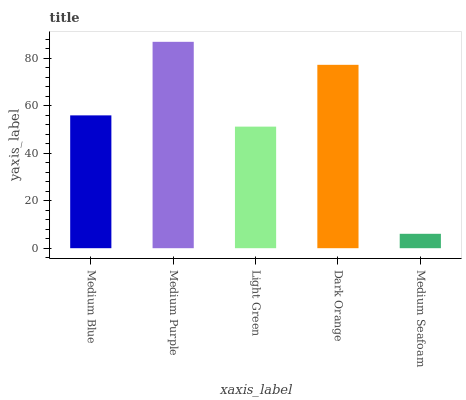Is Medium Seafoam the minimum?
Answer yes or no. Yes. Is Medium Purple the maximum?
Answer yes or no. Yes. Is Light Green the minimum?
Answer yes or no. No. Is Light Green the maximum?
Answer yes or no. No. Is Medium Purple greater than Light Green?
Answer yes or no. Yes. Is Light Green less than Medium Purple?
Answer yes or no. Yes. Is Light Green greater than Medium Purple?
Answer yes or no. No. Is Medium Purple less than Light Green?
Answer yes or no. No. Is Medium Blue the high median?
Answer yes or no. Yes. Is Medium Blue the low median?
Answer yes or no. Yes. Is Light Green the high median?
Answer yes or no. No. Is Medium Seafoam the low median?
Answer yes or no. No. 